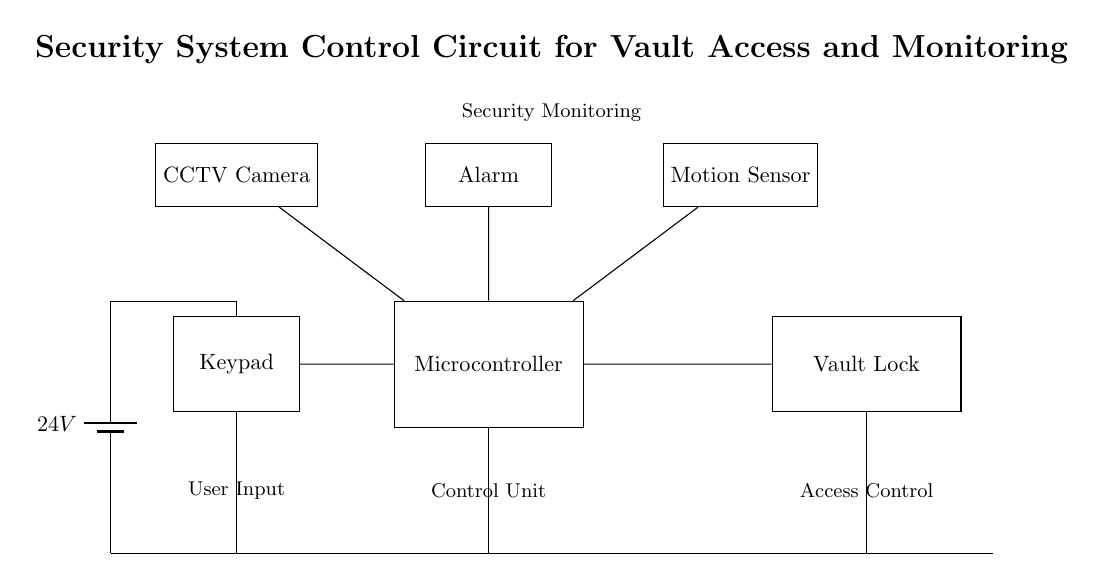What is the main power supply voltage? The voltage is specified as 24V, which is indicated by the battery symbol in the circuit.
Answer: 24V What component receives user input? The component labeled "Keypad" is the one that receives user inputs, as per the label in the diagram.
Answer: Keypad What function does the microcontroller serve in this circuit? The microcontroller serves as the control unit, interfacing with both the keypad and other security components like the lock and alarm.
Answer: Control Unit Which component is responsible for triggering the alarm? The alarm is activated by the microcontroller, which connects directly to the alarm component as shown in the diagram.
Answer: Microcontroller How many components are connected to the microcontroller? There are four components connected to the microcontroller: the lock, the alarm, the motion sensor, and the CCTV camera.
Answer: Four What is the purpose of the motion sensor? The motion sensor is intended for security monitoring, detecting any movement, which is crucial for vault security.
Answer: Security Monitoring What does the CCTV camera represent in this circuit? The CCTV camera represents a security monitoring component, providing visual surveillance of the vault area.
Answer: CCTV Camera 